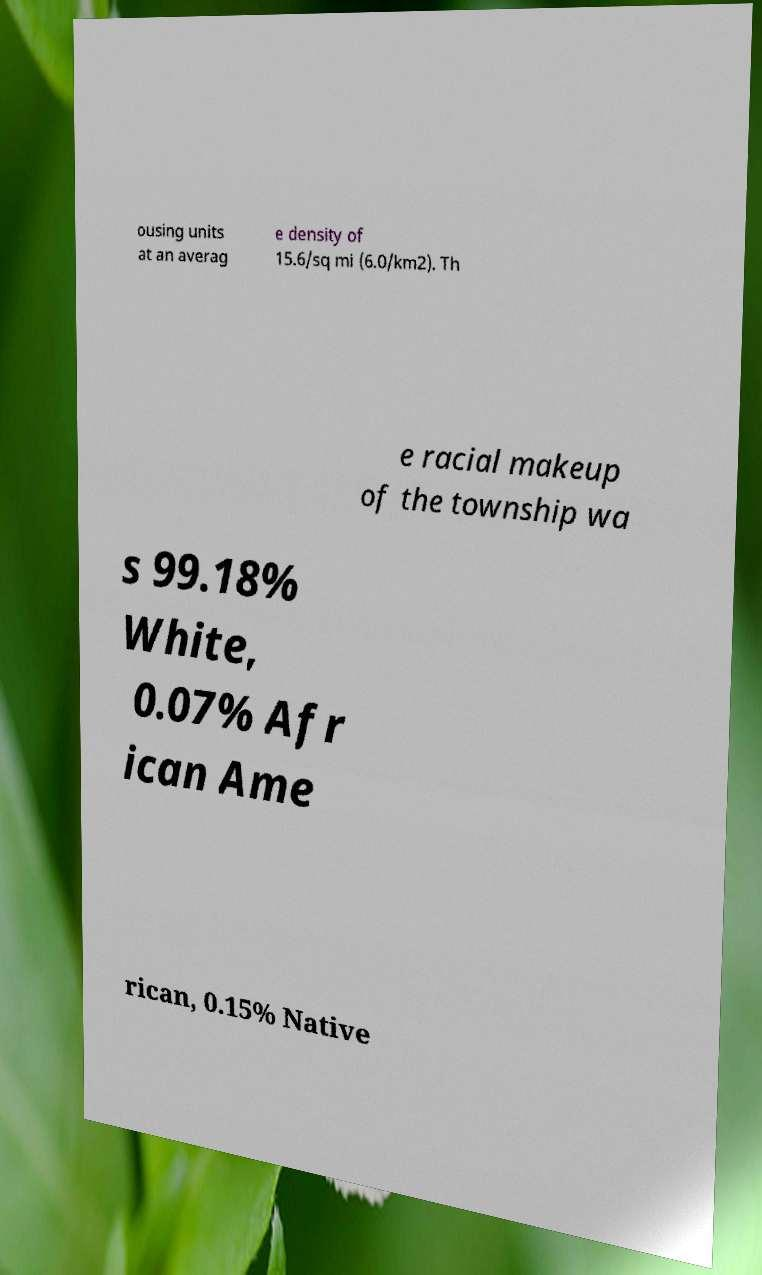Please read and relay the text visible in this image. What does it say? ousing units at an averag e density of 15.6/sq mi (6.0/km2). Th e racial makeup of the township wa s 99.18% White, 0.07% Afr ican Ame rican, 0.15% Native 